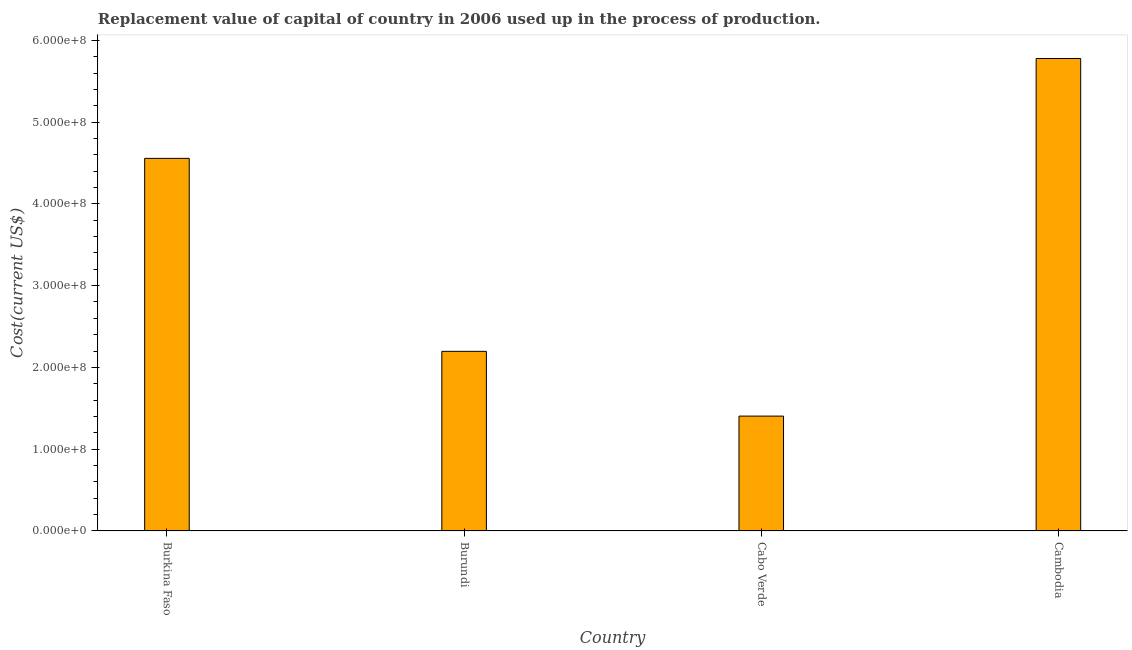Does the graph contain any zero values?
Your answer should be very brief. No. Does the graph contain grids?
Your response must be concise. No. What is the title of the graph?
Give a very brief answer. Replacement value of capital of country in 2006 used up in the process of production. What is the label or title of the X-axis?
Keep it short and to the point. Country. What is the label or title of the Y-axis?
Your answer should be compact. Cost(current US$). What is the consumption of fixed capital in Cabo Verde?
Your answer should be compact. 1.40e+08. Across all countries, what is the maximum consumption of fixed capital?
Provide a succinct answer. 5.78e+08. Across all countries, what is the minimum consumption of fixed capital?
Your answer should be very brief. 1.40e+08. In which country was the consumption of fixed capital maximum?
Ensure brevity in your answer.  Cambodia. In which country was the consumption of fixed capital minimum?
Provide a short and direct response. Cabo Verde. What is the sum of the consumption of fixed capital?
Your answer should be compact. 1.39e+09. What is the difference between the consumption of fixed capital in Burkina Faso and Burundi?
Ensure brevity in your answer.  2.36e+08. What is the average consumption of fixed capital per country?
Give a very brief answer. 3.48e+08. What is the median consumption of fixed capital?
Provide a short and direct response. 3.38e+08. What is the ratio of the consumption of fixed capital in Cabo Verde to that in Cambodia?
Provide a succinct answer. 0.24. What is the difference between the highest and the second highest consumption of fixed capital?
Give a very brief answer. 1.22e+08. Is the sum of the consumption of fixed capital in Burundi and Cabo Verde greater than the maximum consumption of fixed capital across all countries?
Provide a short and direct response. No. What is the difference between the highest and the lowest consumption of fixed capital?
Give a very brief answer. 4.37e+08. How many bars are there?
Keep it short and to the point. 4. What is the difference between two consecutive major ticks on the Y-axis?
Keep it short and to the point. 1.00e+08. What is the Cost(current US$) in Burkina Faso?
Keep it short and to the point. 4.56e+08. What is the Cost(current US$) of Burundi?
Keep it short and to the point. 2.20e+08. What is the Cost(current US$) of Cabo Verde?
Provide a short and direct response. 1.40e+08. What is the Cost(current US$) in Cambodia?
Your answer should be very brief. 5.78e+08. What is the difference between the Cost(current US$) in Burkina Faso and Burundi?
Offer a terse response. 2.36e+08. What is the difference between the Cost(current US$) in Burkina Faso and Cabo Verde?
Offer a terse response. 3.15e+08. What is the difference between the Cost(current US$) in Burkina Faso and Cambodia?
Offer a terse response. -1.22e+08. What is the difference between the Cost(current US$) in Burundi and Cabo Verde?
Your response must be concise. 7.92e+07. What is the difference between the Cost(current US$) in Burundi and Cambodia?
Keep it short and to the point. -3.58e+08. What is the difference between the Cost(current US$) in Cabo Verde and Cambodia?
Give a very brief answer. -4.37e+08. What is the ratio of the Cost(current US$) in Burkina Faso to that in Burundi?
Keep it short and to the point. 2.07. What is the ratio of the Cost(current US$) in Burkina Faso to that in Cabo Verde?
Your answer should be very brief. 3.24. What is the ratio of the Cost(current US$) in Burkina Faso to that in Cambodia?
Your response must be concise. 0.79. What is the ratio of the Cost(current US$) in Burundi to that in Cabo Verde?
Your response must be concise. 1.56. What is the ratio of the Cost(current US$) in Burundi to that in Cambodia?
Your answer should be compact. 0.38. What is the ratio of the Cost(current US$) in Cabo Verde to that in Cambodia?
Make the answer very short. 0.24. 